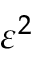<formula> <loc_0><loc_0><loc_500><loc_500>\varepsilon ^ { 2 }</formula> 